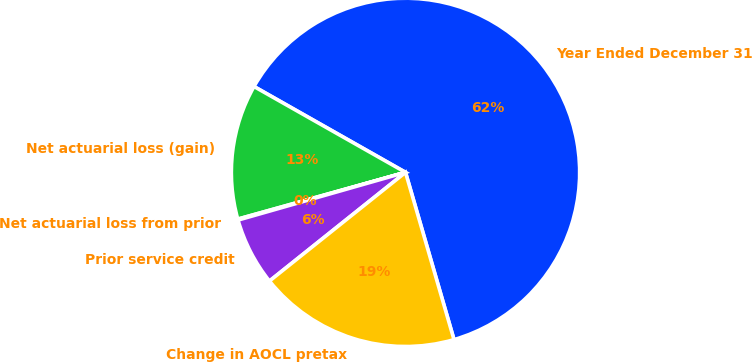Convert chart. <chart><loc_0><loc_0><loc_500><loc_500><pie_chart><fcel>Year Ended December 31<fcel>Net actuarial loss (gain)<fcel>Net actuarial loss from prior<fcel>Prior service credit<fcel>Change in AOCL pretax<nl><fcel>62.3%<fcel>12.53%<fcel>0.09%<fcel>6.31%<fcel>18.76%<nl></chart> 